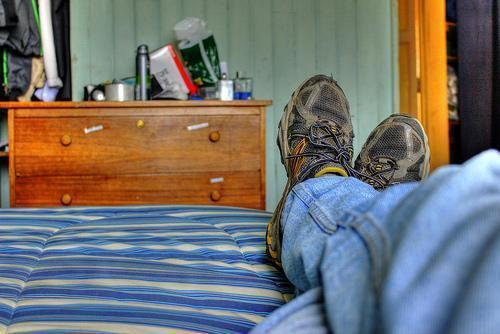How many people are in the picture?
Give a very brief answer. 1. 